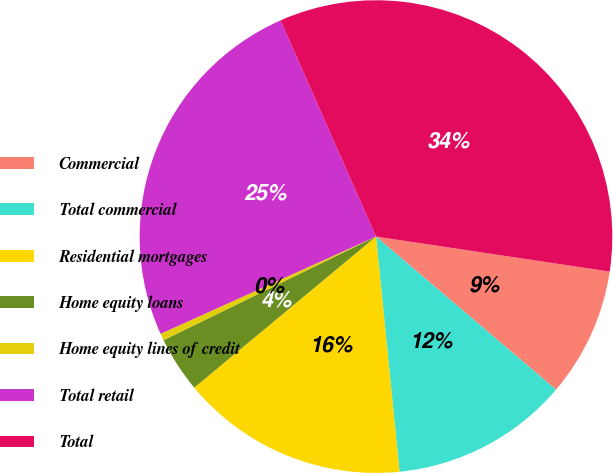Convert chart to OTSL. <chart><loc_0><loc_0><loc_500><loc_500><pie_chart><fcel>Commercial<fcel>Total commercial<fcel>Residential mortgages<fcel>Home equity loans<fcel>Home equity lines of credit<fcel>Total retail<fcel>Total<nl><fcel>8.85%<fcel>12.2%<fcel>15.55%<fcel>3.82%<fcel>0.47%<fcel>25.14%<fcel>33.99%<nl></chart> 